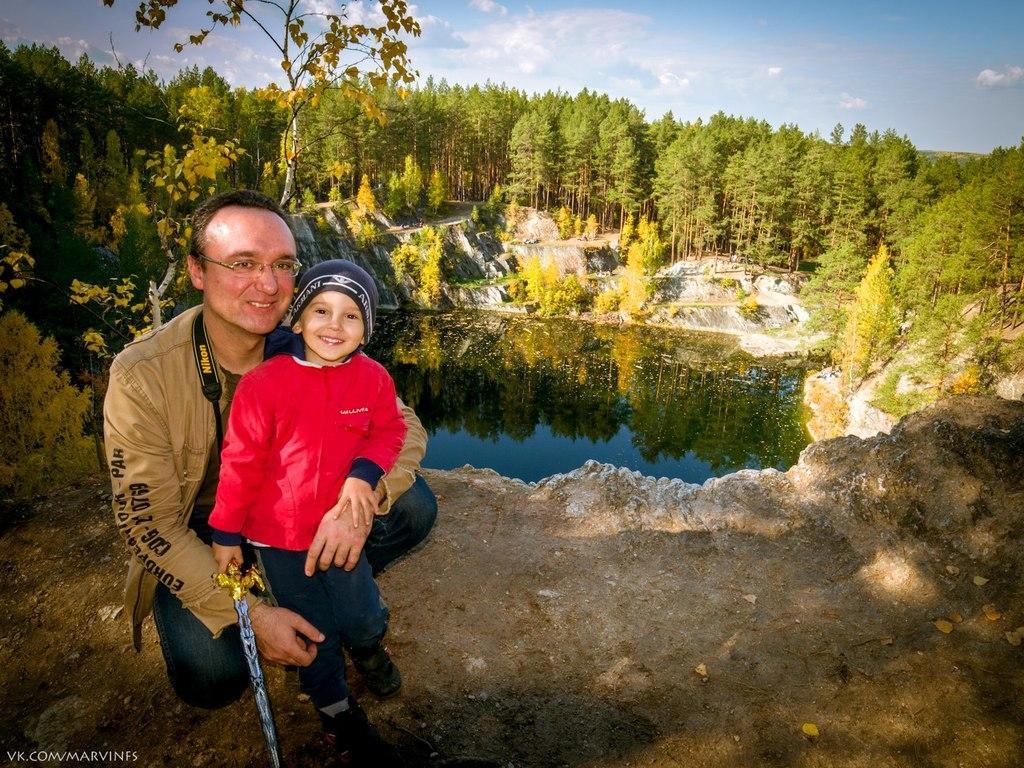Describe this image in one or two sentences. In the front of the image I can see a person and boy. Boy is holding a sword. In the background of the image there are trees, plants, water and sky.   